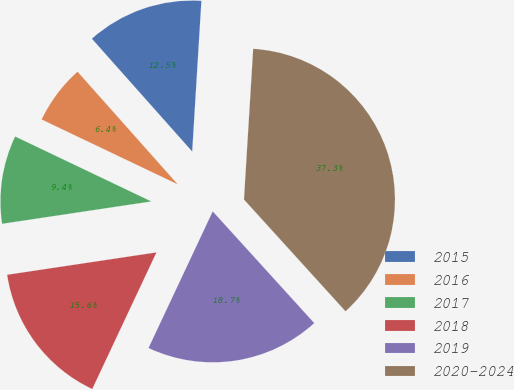Convert chart. <chart><loc_0><loc_0><loc_500><loc_500><pie_chart><fcel>2015<fcel>2016<fcel>2017<fcel>2018<fcel>2019<fcel>2020-2024<nl><fcel>12.54%<fcel>6.35%<fcel>9.45%<fcel>15.64%<fcel>18.73%<fcel>37.29%<nl></chart> 